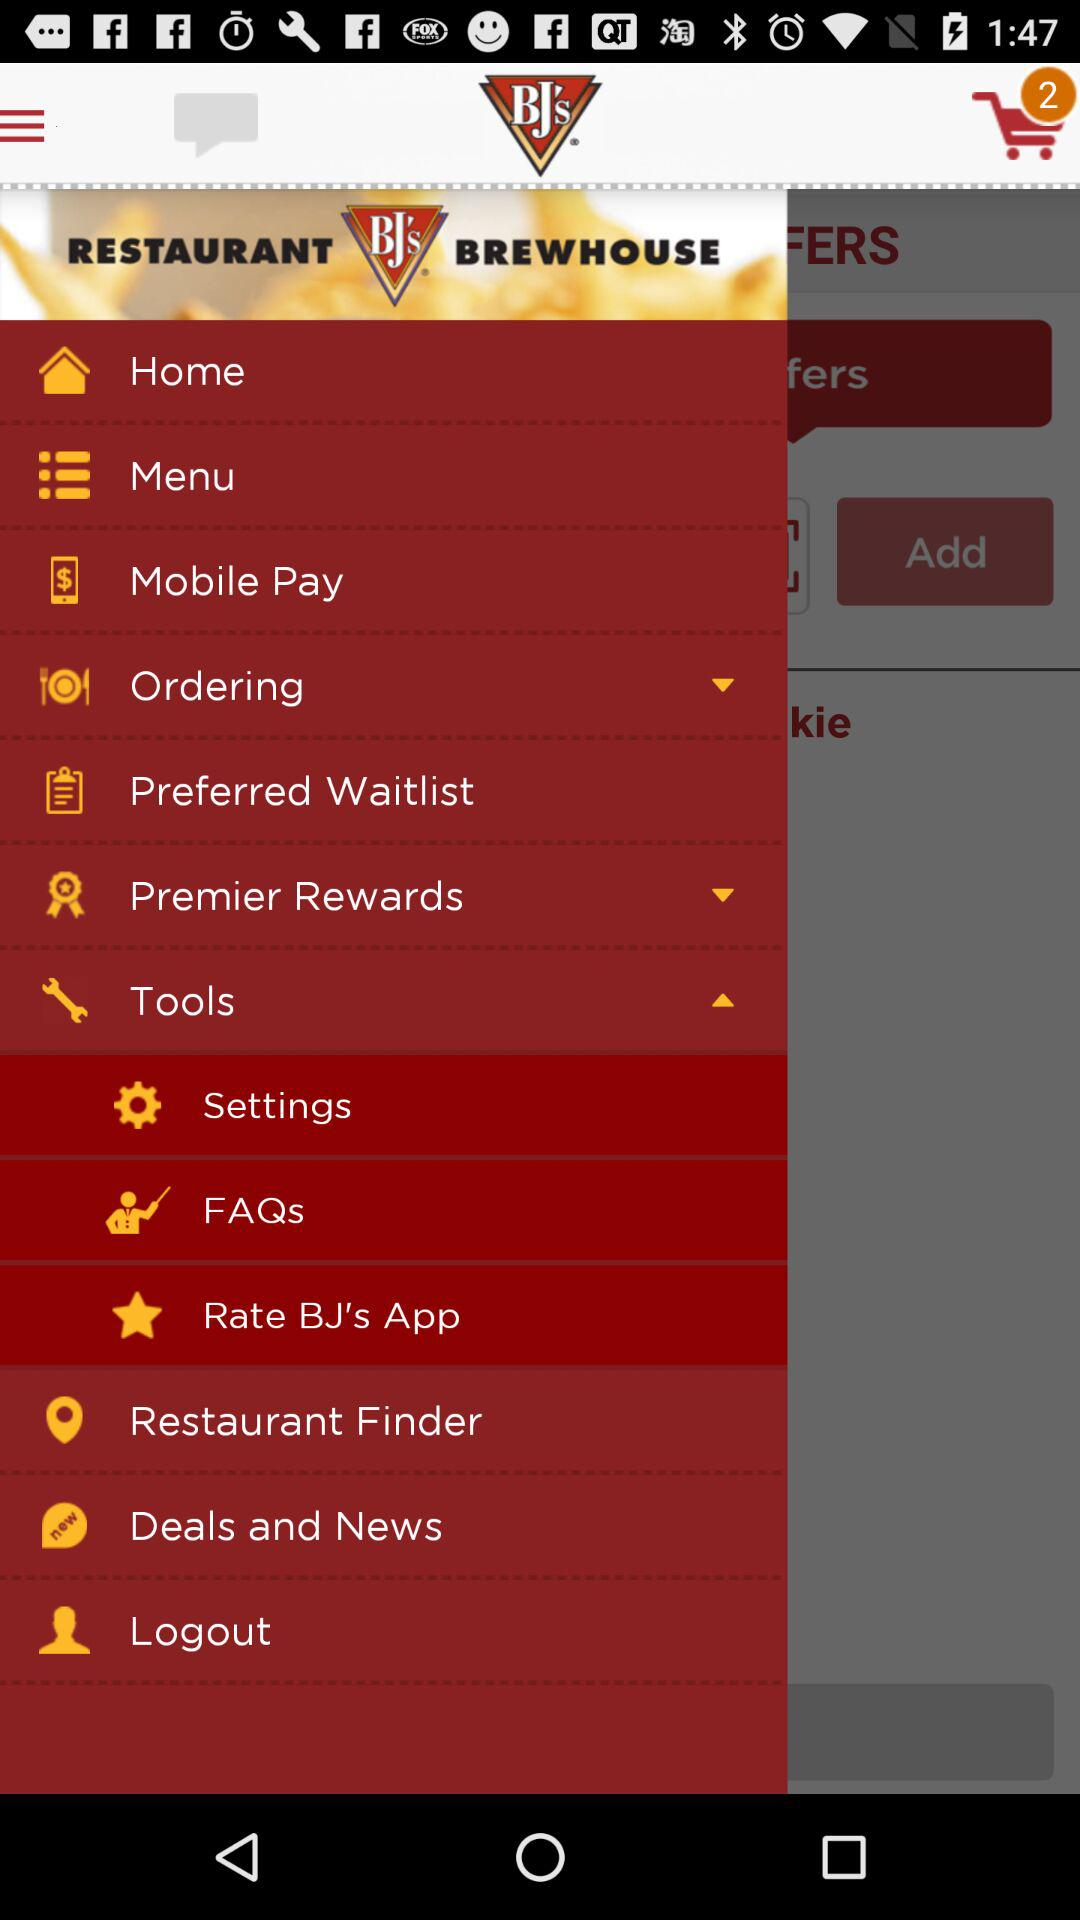How many items are there in the cart? There are 2 items in the cart. 